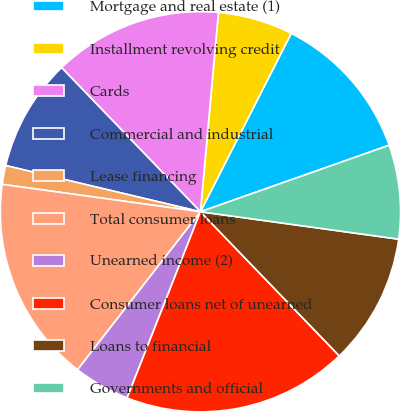<chart> <loc_0><loc_0><loc_500><loc_500><pie_chart><fcel>Mortgage and real estate (1)<fcel>Installment revolving credit<fcel>Cards<fcel>Commercial and industrial<fcel>Lease financing<fcel>Total consumer loans<fcel>Unearned income (2)<fcel>Consumer loans net of unearned<fcel>Loans to financial<fcel>Governments and official<nl><fcel>12.12%<fcel>6.06%<fcel>13.64%<fcel>9.09%<fcel>1.52%<fcel>16.67%<fcel>4.55%<fcel>18.18%<fcel>10.61%<fcel>7.58%<nl></chart> 